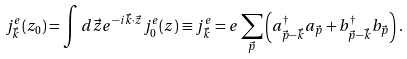<formula> <loc_0><loc_0><loc_500><loc_500>j _ { \vec { k } } ^ { e } ( z _ { 0 } ) = \int d { \vec { z } } e ^ { - i { \vec { k } } \cdot { \vec { z } } } j _ { 0 } ^ { e } ( z ) \equiv j _ { \vec { k } } ^ { e } = e \sum _ { \vec { p } } \left ( a _ { { \vec { p } } - { \vec { k } } } ^ { \dag } a _ { \vec { p } } + b _ { { \vec { p } } - { \vec { k } } } ^ { \dag } b _ { \vec { p } } \right ) .</formula> 